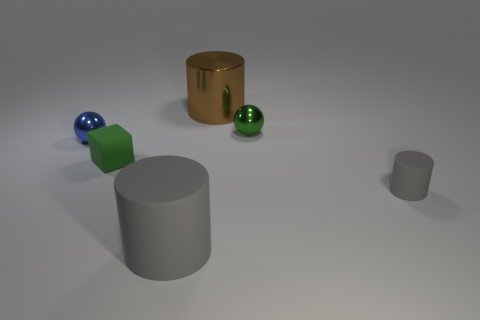Subtract all big cylinders. How many cylinders are left? 1 Subtract all gray spheres. How many gray cylinders are left? 2 Add 4 tiny objects. How many objects exist? 10 Subtract all brown cylinders. How many cylinders are left? 2 Subtract 1 spheres. How many spheres are left? 1 Subtract all spheres. How many objects are left? 4 Add 2 big things. How many big things are left? 4 Add 2 gray rubber cylinders. How many gray rubber cylinders exist? 4 Subtract 0 green cylinders. How many objects are left? 6 Subtract all purple blocks. Subtract all purple spheres. How many blocks are left? 1 